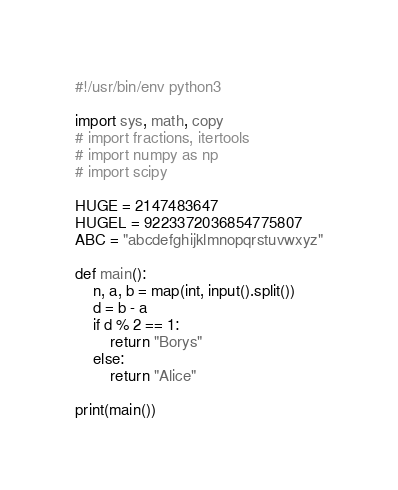Convert code to text. <code><loc_0><loc_0><loc_500><loc_500><_Python_>#!/usr/bin/env python3

import sys, math, copy
# import fractions, itertools
# import numpy as np
# import scipy

HUGE = 2147483647
HUGEL = 9223372036854775807
ABC = "abcdefghijklmnopqrstuvwxyz"

def main():
    n, a, b = map(int, input().split())
    d = b - a
    if d % 2 == 1:
        return "Borys"
    else:
        return "Alice"

print(main())
</code> 